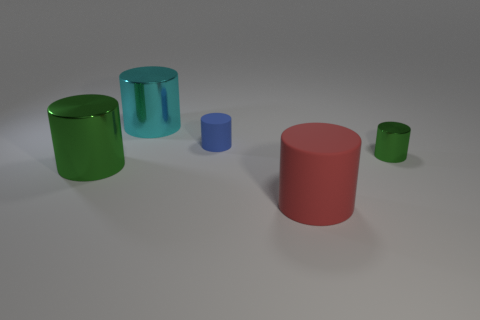Subtract 1 cylinders. How many cylinders are left? 4 Subtract all blue cylinders. How many cylinders are left? 4 Subtract all red cylinders. How many cylinders are left? 4 Add 1 big metal objects. How many objects exist? 6 Subtract all yellow cylinders. Subtract all red cubes. How many cylinders are left? 5 Add 4 red cylinders. How many red cylinders exist? 5 Subtract 0 purple spheres. How many objects are left? 5 Subtract all big shiny objects. Subtract all large green metallic cylinders. How many objects are left? 2 Add 3 big green cylinders. How many big green cylinders are left? 4 